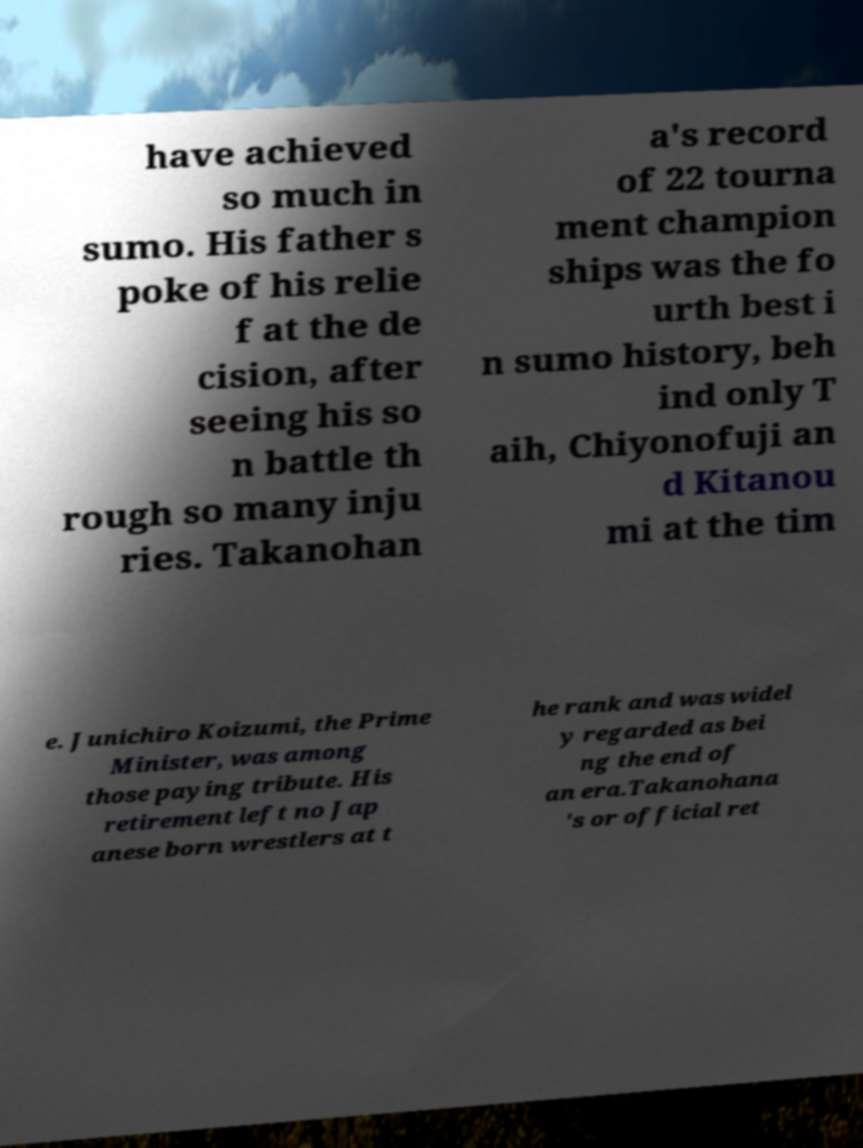For documentation purposes, I need the text within this image transcribed. Could you provide that? have achieved so much in sumo. His father s poke of his relie f at the de cision, after seeing his so n battle th rough so many inju ries. Takanohan a's record of 22 tourna ment champion ships was the fo urth best i n sumo history, beh ind only T aih, Chiyonofuji an d Kitanou mi at the tim e. Junichiro Koizumi, the Prime Minister, was among those paying tribute. His retirement left no Jap anese born wrestlers at t he rank and was widel y regarded as bei ng the end of an era.Takanohana 's or official ret 